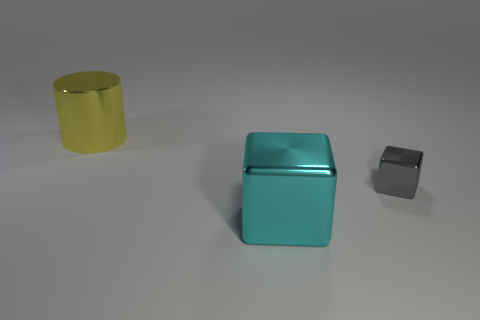Are there more cubes that are to the right of the yellow metallic object than large metallic things?
Give a very brief answer. No. Is there a large gray object that has the same shape as the cyan metallic thing?
Your answer should be very brief. No. The small shiny object is what color?
Offer a terse response. Gray. What number of cubes are in front of the block that is to the right of the big shiny object in front of the tiny gray object?
Offer a very short reply. 1. There is a large yellow cylinder; are there any big metal objects right of it?
Give a very brief answer. Yes. How many big yellow things are made of the same material as the small gray block?
Offer a terse response. 1. How many objects are tiny blocks or blue things?
Give a very brief answer. 1. Is there a tiny cyan metal sphere?
Provide a succinct answer. No. Is the number of big yellow metallic cylinders in front of the yellow metallic thing less than the number of small things?
Keep it short and to the point. Yes. There is a yellow object that is the same size as the cyan block; what is it made of?
Offer a very short reply. Metal. 